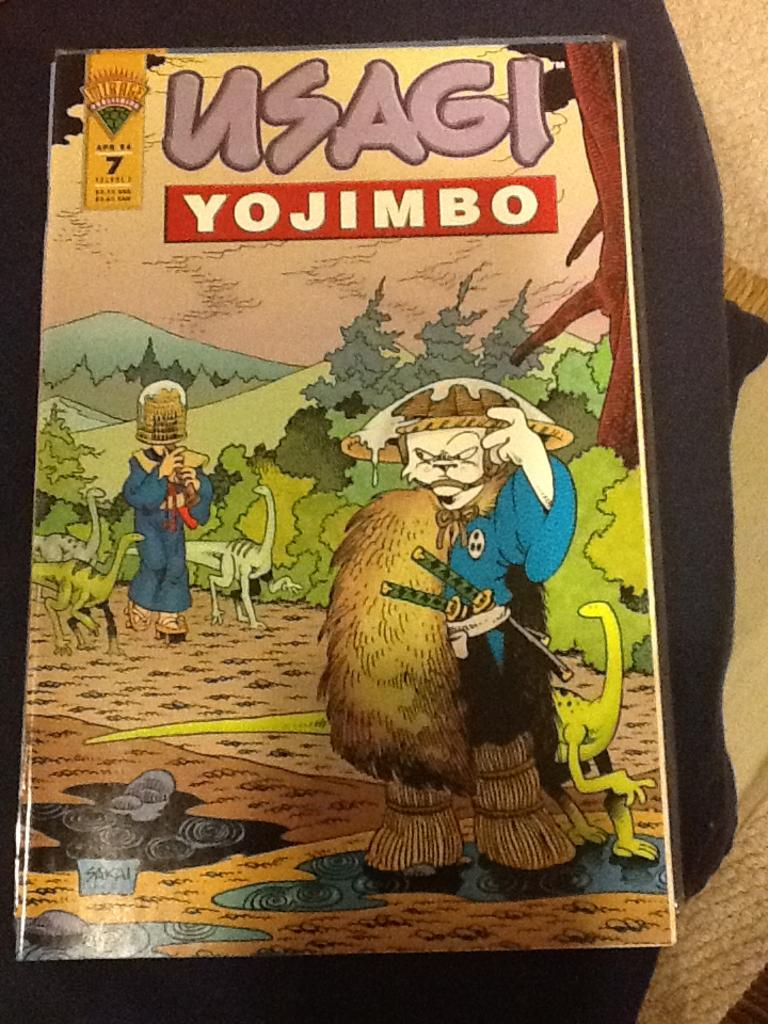What is the main theme of the book cover? The main theme of the book cover is dragons, as they are prominently featured on the cover. What other elements are present on the book cover? There are trees, mountains, swords, text, two persons, and clouds in the sky on the cover. Can you describe the setting depicted on the book cover? The setting includes mountains, trees, and clouds in the sky. How many people are depicted on the book cover? There are two persons on the cover. What type of lipstick is the dragon wearing on the book cover? There is no lipstick or dragon wearing lipstick present on the book cover. 